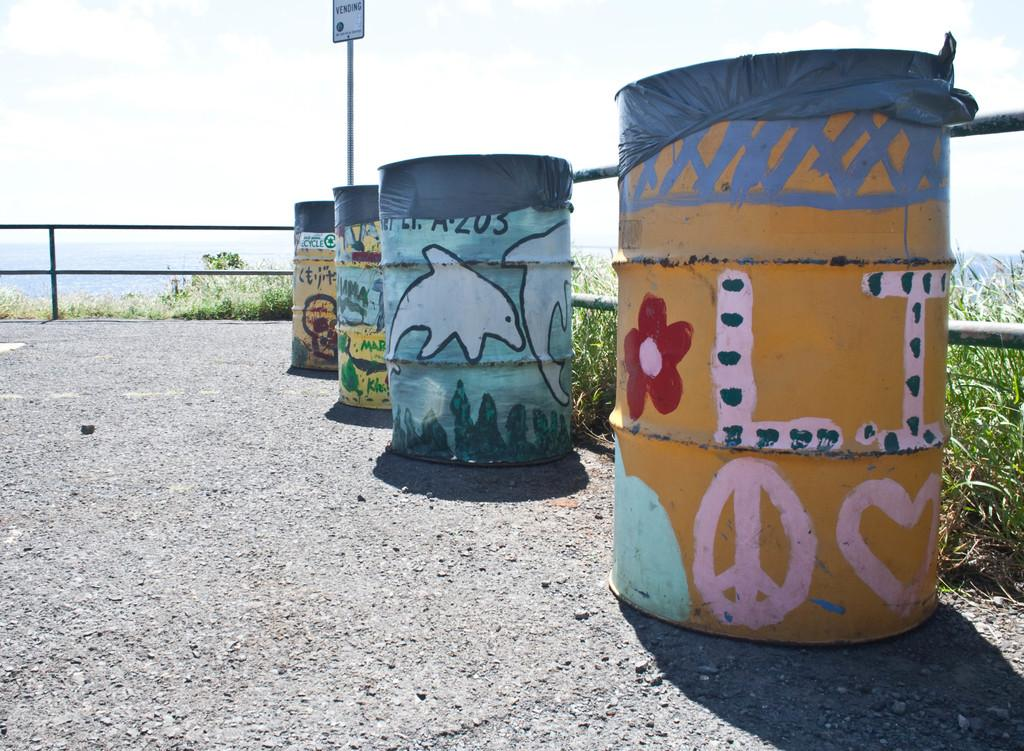What objects are on the ground in the image? There are four painted barrels with covers on the ground in the image. What can be seen attached to a pole in the image? A name board is attached to a pole in the image. What type of structures can be seen in the image? There are fences in the image. What type of vegetation is present in the image? Plants are present in the image. What is visible in the background of the image? The sky with clouds is visible in the background of the image. How many corn stalks can be seen growing in the image? There are no corn stalks present in the image. What type of grip can be seen on the fences in the image? There is no grip visible on the fences in the image. 